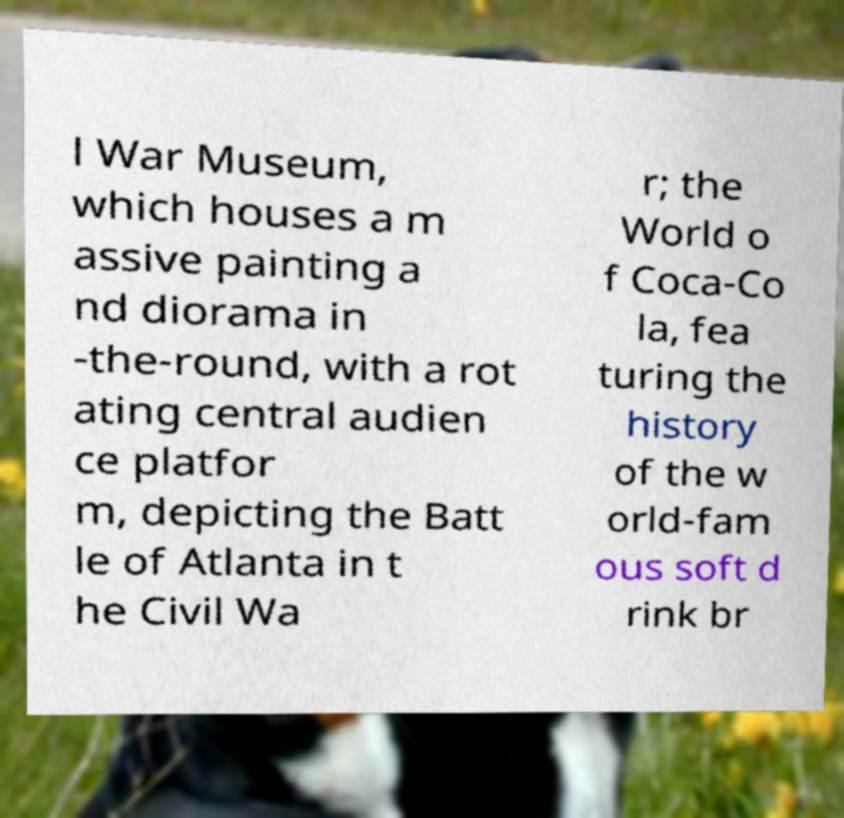Can you accurately transcribe the text from the provided image for me? l War Museum, which houses a m assive painting a nd diorama in -the-round, with a rot ating central audien ce platfor m, depicting the Batt le of Atlanta in t he Civil Wa r; the World o f Coca-Co la, fea turing the history of the w orld-fam ous soft d rink br 